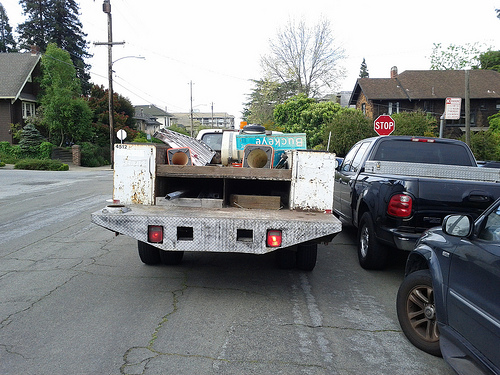Is there anything indicating where the truck may be headed? There is no direct indication of the truck's destination on the truck itself. However, given the mix of items, it could be en route to a waste disposal site, a recycling center, or perhaps to a location where these items will be sorted and processed for different purposes. 